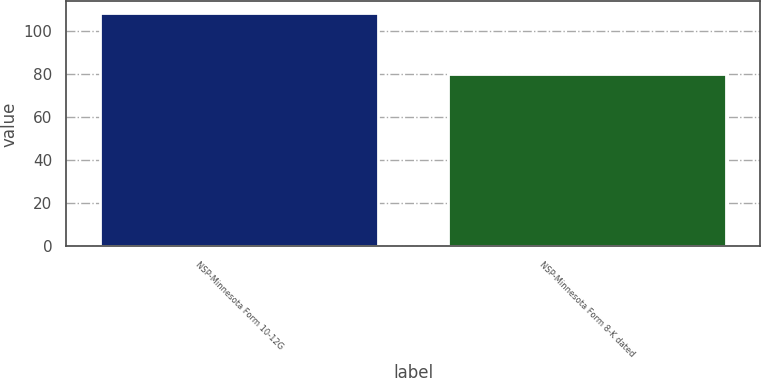Convert chart to OTSL. <chart><loc_0><loc_0><loc_500><loc_500><bar_chart><fcel>NSP-Minnesota Form 10-12G<fcel>NSP-Minnesota Form 8-K dated<nl><fcel>108.51<fcel>80.01<nl></chart> 